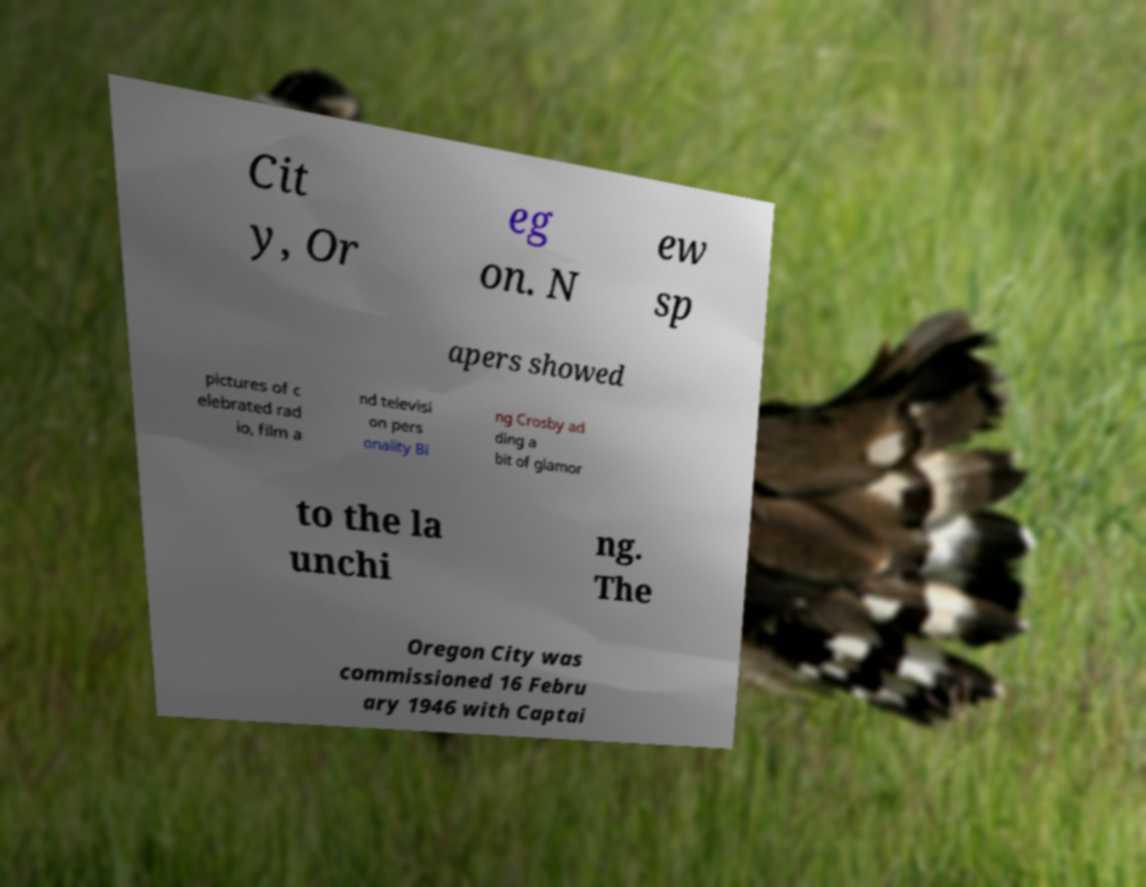Can you read and provide the text displayed in the image?This photo seems to have some interesting text. Can you extract and type it out for me? Cit y, Or eg on. N ew sp apers showed pictures of c elebrated rad io, film a nd televisi on pers onality Bi ng Crosby ad ding a bit of glamor to the la unchi ng. The Oregon City was commissioned 16 Febru ary 1946 with Captai 